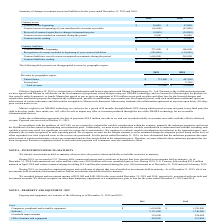From Resonant's financial document, What are the components recorded under cost? The document contains multiple relevant values: Computers, peripheral and scientific equipment, Software, Leasehold improvements, Office furniture and equipment. From the document: "Leasehold improvements 310,000 294,000 Office furniture and equipment 424,000 391,000 Computers, peripheral and scientific equipment $ 1,654,000 $ 1,3..." Also, What was the cost of disposals in 2019? Based on the financial document, the answer is $31,000. Also, What was the reason for the disposals in 2018? Based on the financial document, the answer is Relocating our corporate offices and writing off the fully amortized leasehold improvements related to our former office.. Additionally, Which year has a higher depreciation? According to the financial document, 2019. The relevant text states: "and liabilities for the years ended December 31, 2019 and 2018: and liabilities for the years ended December 31, 2019 and 2018:..." Also, can you calculate: What was the change in software cost from 2018 to 2019? Based on the calculation: 2,131,000 - 1,749,000 , the result is 382000. This is based on the information: "Software 2,131,000 1,749,000 Software 2,131,000 1,749,000..." The key data points involved are: 1,749,000, 2,131,000. Also, can you calculate: What was the percentage change in the net property and equipment? To answer this question, I need to perform calculations using the financial data. The calculation is: ($1,885,000 - $1,987,000)/$1,987,000 , which equals -5.13 (percentage). The key data points involved are: 1,885,000, 1,987,000. 